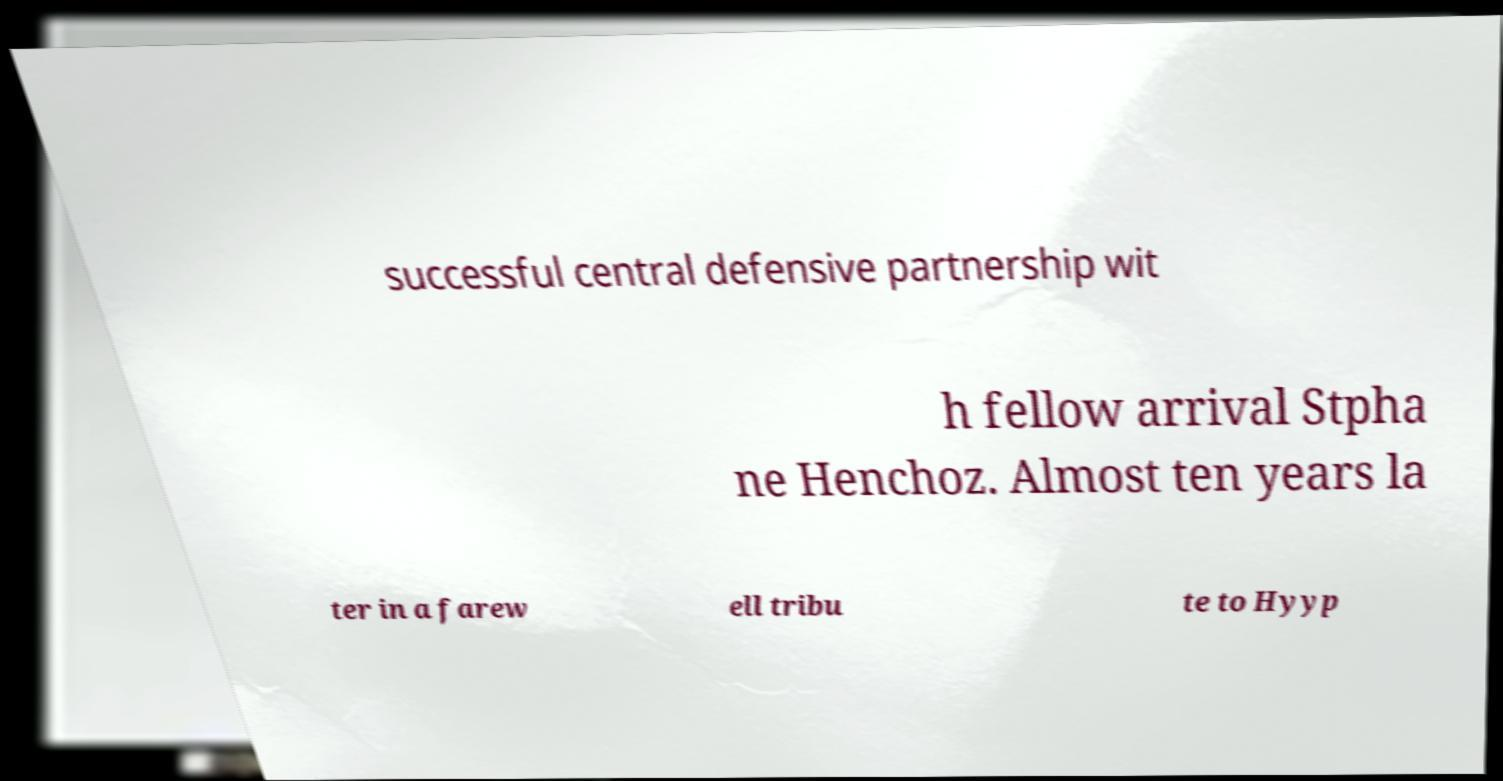Please read and relay the text visible in this image. What does it say? successful central defensive partnership wit h fellow arrival Stpha ne Henchoz. Almost ten years la ter in a farew ell tribu te to Hyyp 